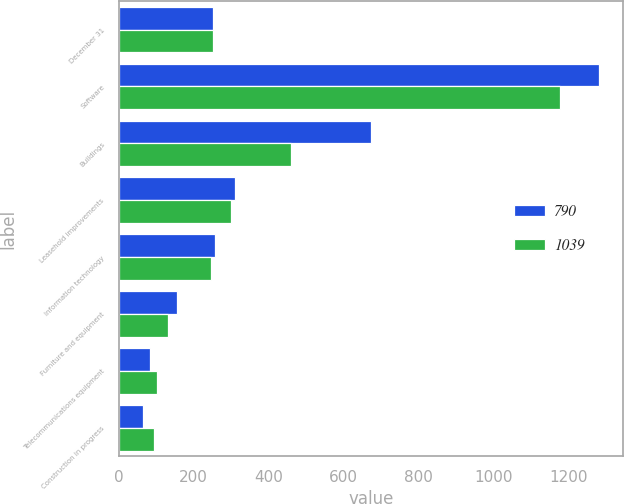Convert chart to OTSL. <chart><loc_0><loc_0><loc_500><loc_500><stacked_bar_chart><ecel><fcel>December 31<fcel>Software<fcel>Buildings<fcel>Leasehold improvements<fcel>Information technology<fcel>Furniture and equipment<fcel>Telecommunications equipment<fcel>Construction in progress<nl><fcel>790<fcel>251<fcel>1281<fcel>673<fcel>310<fcel>257<fcel>154<fcel>83<fcel>64<nl><fcel>1039<fcel>251<fcel>1177<fcel>460<fcel>300<fcel>245<fcel>131<fcel>102<fcel>95<nl></chart> 